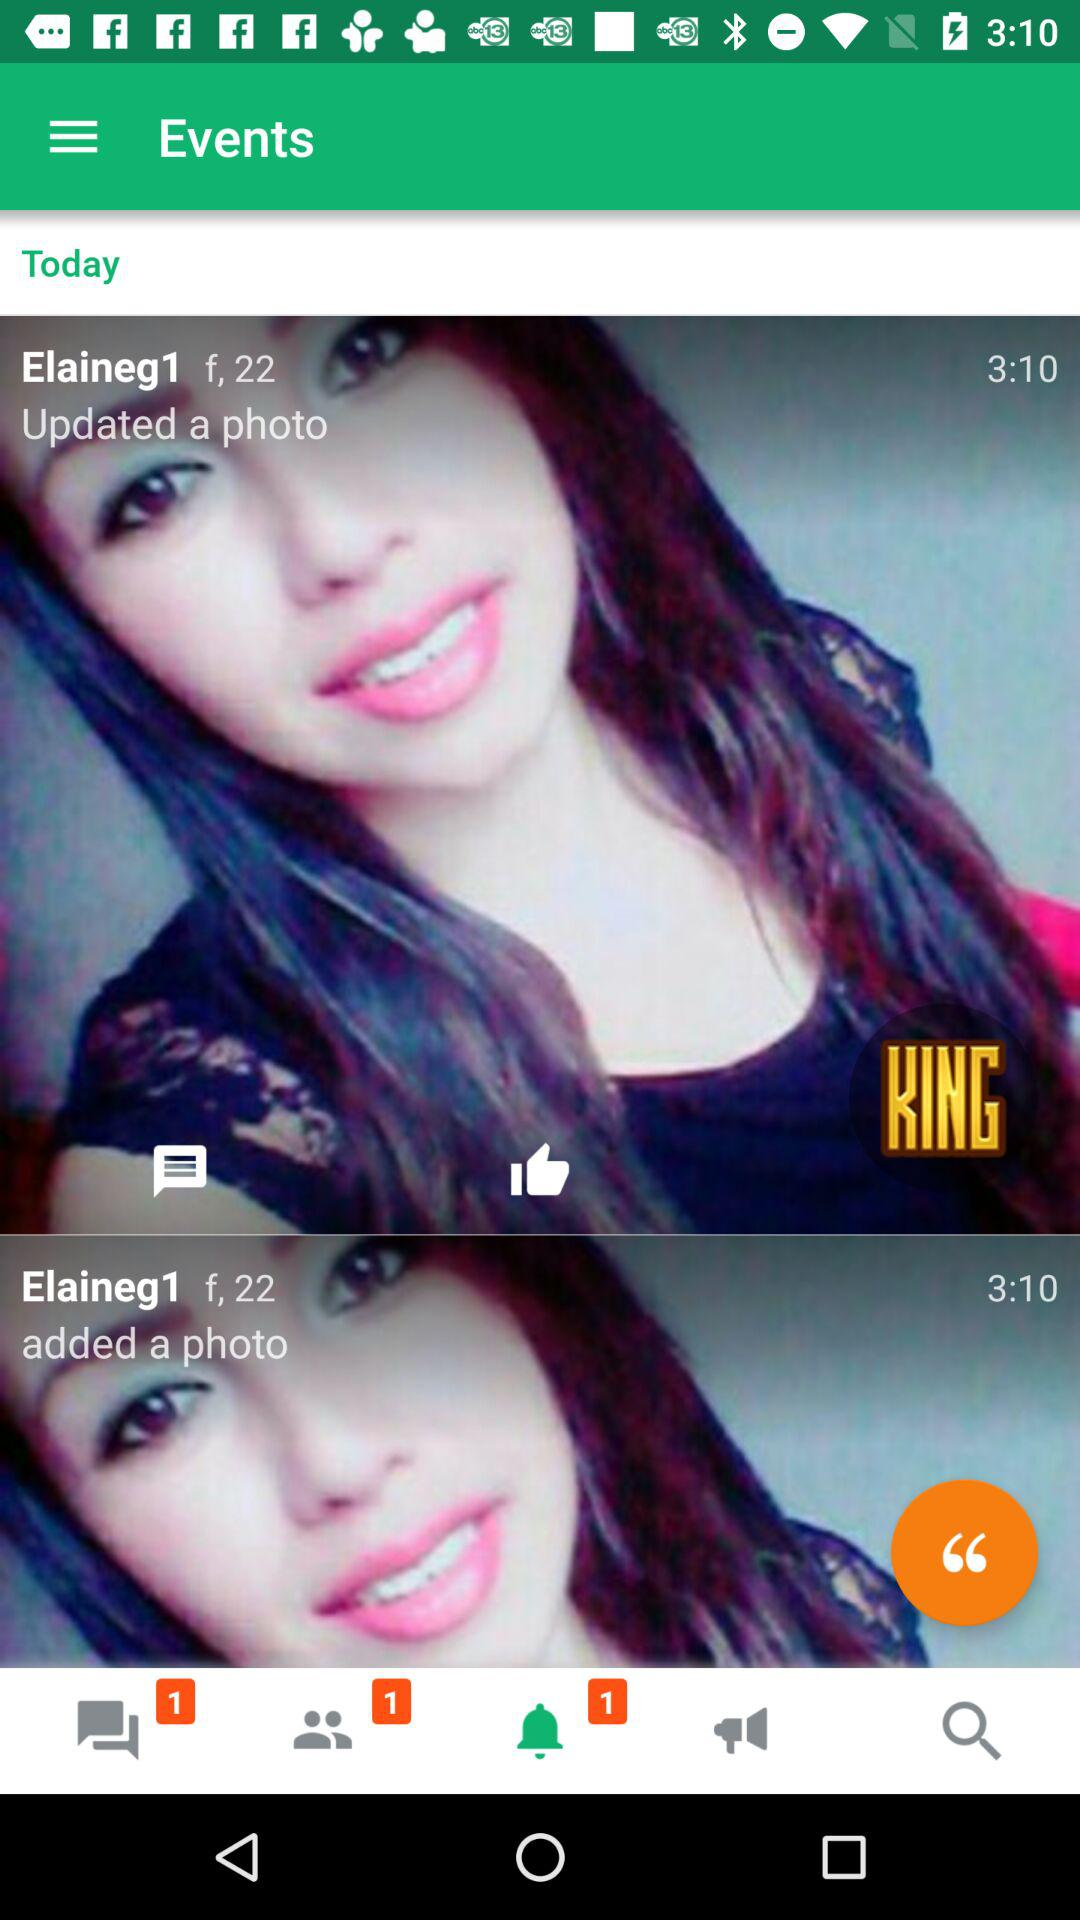How many new notifications are there? There is 1 new notification. 